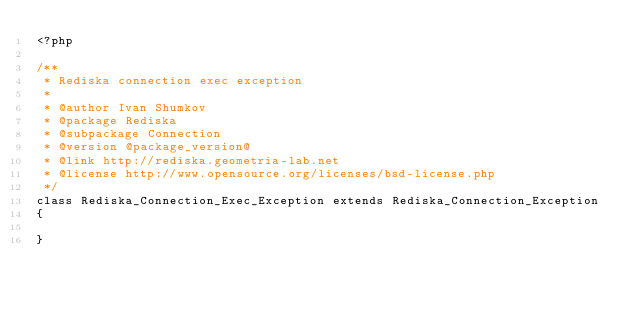<code> <loc_0><loc_0><loc_500><loc_500><_PHP_><?php

/**
 * Rediska connection exec exception
 * 
 * @author Ivan Shumkov
 * @package Rediska
 * @subpackage Connection
 * @version @package_version@
 * @link http://rediska.geometria-lab.net
 * @license http://www.opensource.org/licenses/bsd-license.php
 */
class Rediska_Connection_Exec_Exception extends Rediska_Connection_Exception
{
    
}</code> 